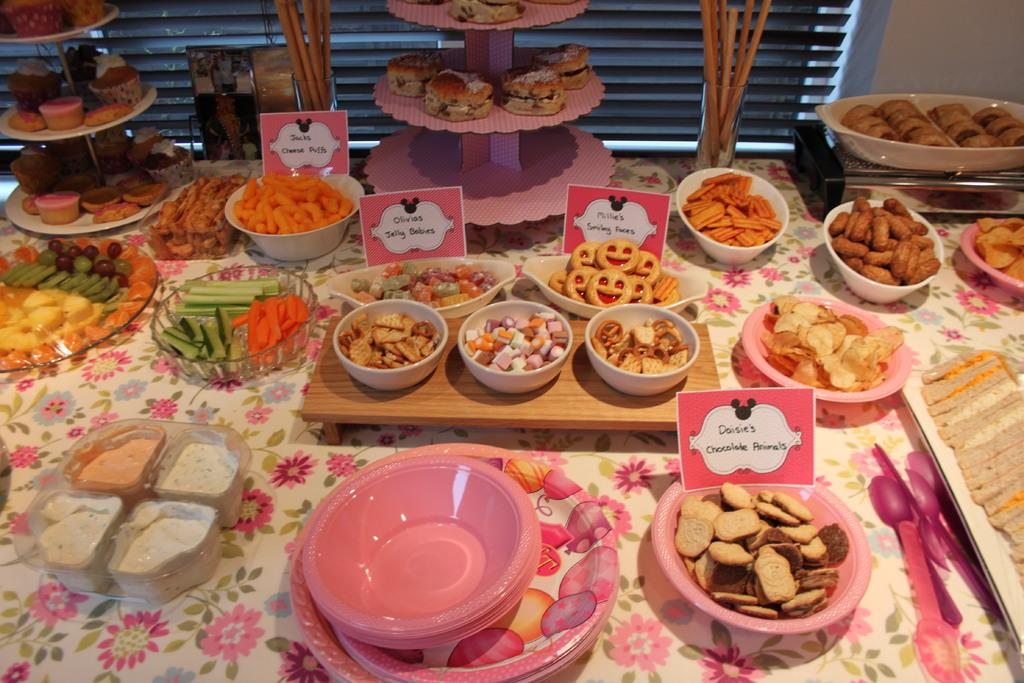What types of tableware are present in the image? There are bowls, plates, and spoons in the image. What can be found on the table in the image? There are food items, name cards, and chopsticks in the image. Can you describe the background of the image? There is a wall and a curtain in the background of the image. What type of shade can be seen at the seashore in the image? There is no shade or seashore present in the image; it features a table setting with various tableware and food items. 